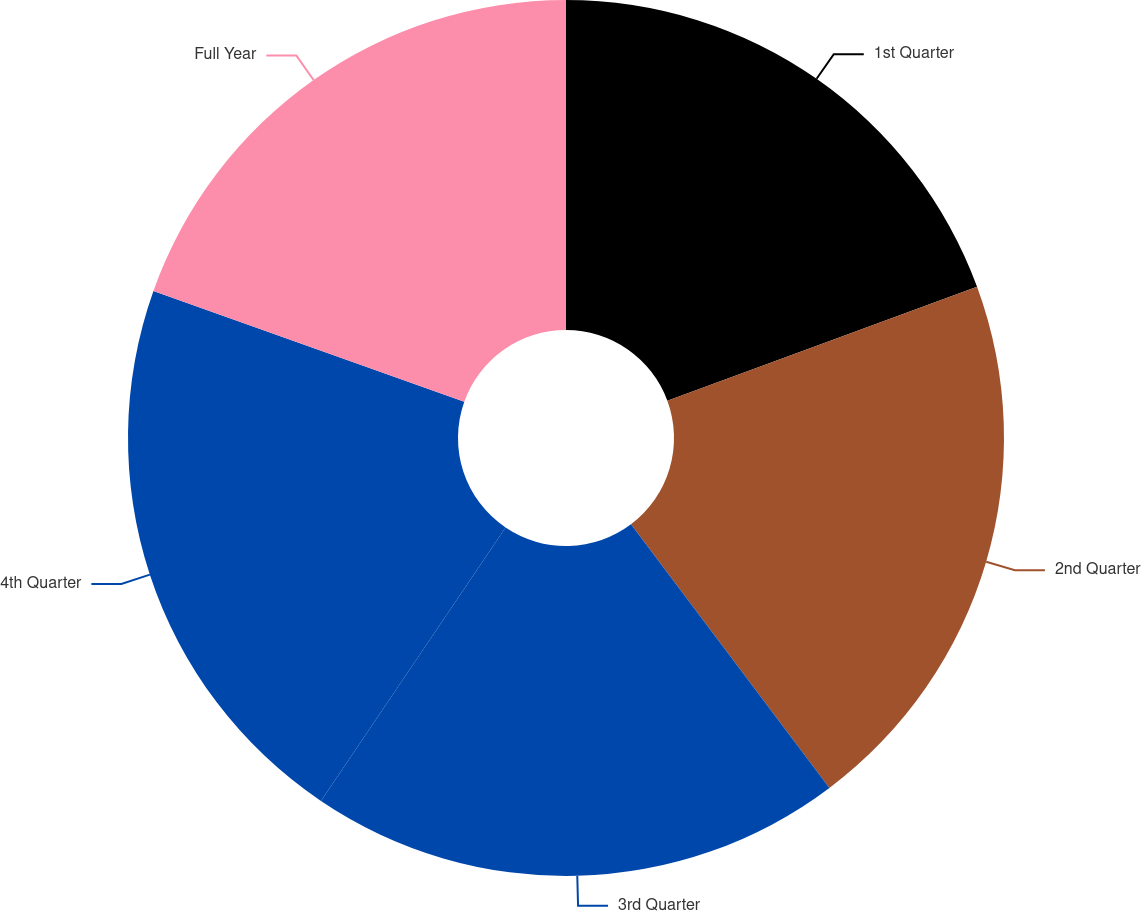Convert chart. <chart><loc_0><loc_0><loc_500><loc_500><pie_chart><fcel>1st Quarter<fcel>2nd Quarter<fcel>3rd Quarter<fcel>4th Quarter<fcel>Full Year<nl><fcel>19.39%<fcel>20.34%<fcel>19.72%<fcel>21.0%<fcel>19.55%<nl></chart> 